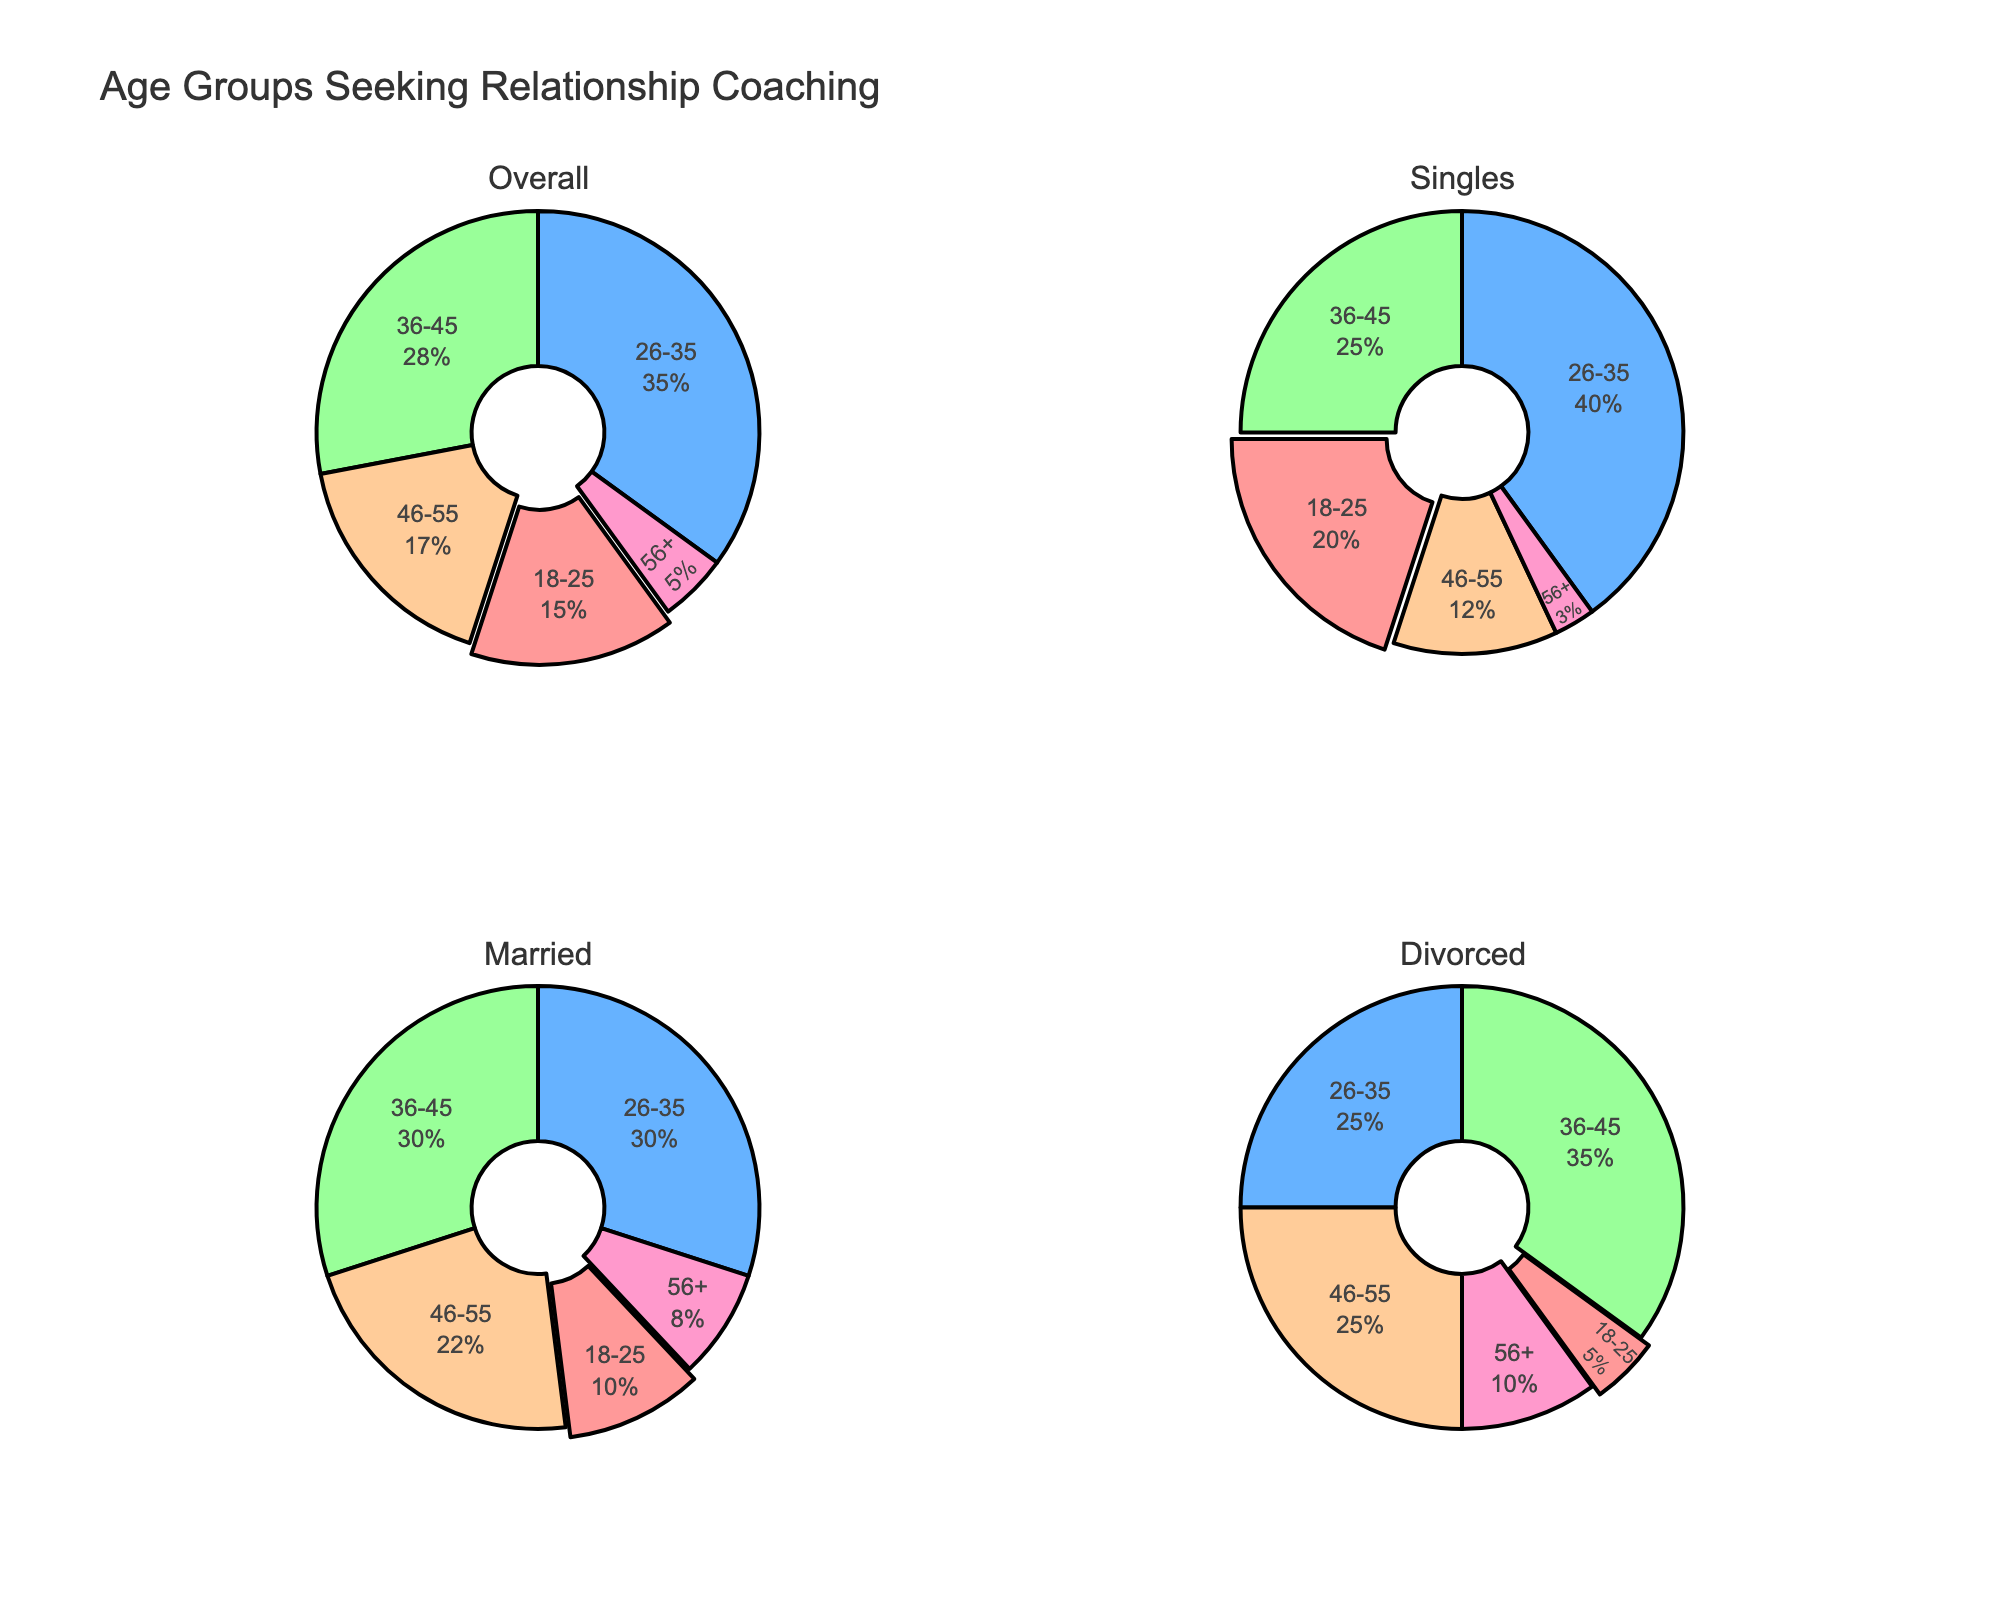What is the overall age group with the highest percentage seeking relationship coaching? The overall pie chart shows the percentage breakdown of all age groups. The 26-35 age group has the largest sector with 35%.
Answer: 26-35 What percentage of singles seeking relationship coaching belong to the 36-45 age group? Look at the Singles pie chart. The slice for the 36-45 age group shows a percentage of 25%.
Answer: 25% Which age group has the smallest percentage representation among married individuals seeking coaching? Refer to the Married pie chart. The slice for the 18-25 age group is the smallest with 10%.
Answer: 18-25 What is the total percentage of individuals aged 46-55 among the singles and married groups combined? Add the percentages from the Singles and Married pie charts for the 46-55 age group: 12% (Singles) + 22% (Married) = 34%.
Answer: 34% How does the percentage of divorced individuals aged 36-45 compare to those aged 56+? Compare the slices in the Divorced pie chart. The 36-45 age group has 35%, while the 56+ group has 10%.
Answer: 36-45 age group is greater What are the top two age groups among divorced individuals seeking relationship coaching? Look at the Divorced pie chart. The 36-45 age group is the largest with 35%, followed by the 46-55 age group with 25%.
Answer: 36-45, 46-55 Which category has the most balanced percentage distribution across all age groups? Analyze the pie charts to see which has the closest percentages. The Married chart shows smaller variation compared to others, with age groups ranging from 8% to 30%.
Answer: Married For individuals aged 26-35, how do the percentages vary across the overall, singles, married, and divorced categories? Review each pie chart for the 26-35 age group: Overall (35%), Singles (40%), Married (30%), Divorced (25%).
Answer: 35% overall, 40% singles, 30% married, 25% divorced 